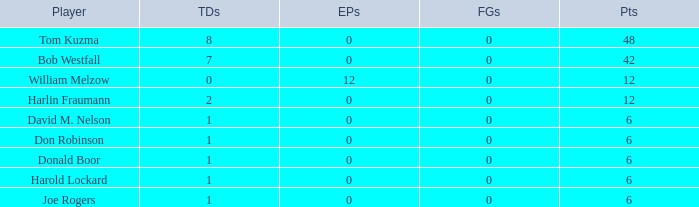Name the points for donald boor 6.0. 